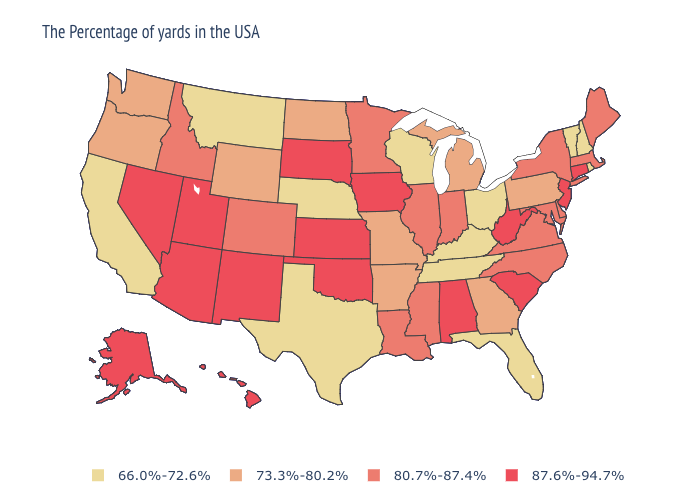Does the first symbol in the legend represent the smallest category?
Quick response, please. Yes. What is the lowest value in the West?
Write a very short answer. 66.0%-72.6%. Which states hav the highest value in the South?
Concise answer only. South Carolina, West Virginia, Alabama, Oklahoma. What is the lowest value in the USA?
Give a very brief answer. 66.0%-72.6%. Does Nebraska have the lowest value in the USA?
Concise answer only. Yes. Which states hav the highest value in the MidWest?
Give a very brief answer. Iowa, Kansas, South Dakota. Which states have the lowest value in the South?
Answer briefly. Florida, Kentucky, Tennessee, Texas. Does Tennessee have the lowest value in the South?
Keep it brief. Yes. What is the highest value in the USA?
Concise answer only. 87.6%-94.7%. Does Alabama have a higher value than Rhode Island?
Concise answer only. Yes. Name the states that have a value in the range 80.7%-87.4%?
Answer briefly. Maine, Massachusetts, New York, Delaware, Maryland, Virginia, North Carolina, Indiana, Illinois, Mississippi, Louisiana, Minnesota, Colorado, Idaho. What is the value of Nevada?
Be succinct. 87.6%-94.7%. What is the highest value in states that border Arizona?
Quick response, please. 87.6%-94.7%. Name the states that have a value in the range 66.0%-72.6%?
Write a very short answer. Rhode Island, New Hampshire, Vermont, Ohio, Florida, Kentucky, Tennessee, Wisconsin, Nebraska, Texas, Montana, California. What is the lowest value in states that border West Virginia?
Write a very short answer. 66.0%-72.6%. 